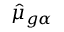Convert formula to latex. <formula><loc_0><loc_0><loc_500><loc_500>\hat { \mu } _ { g \alpha }</formula> 